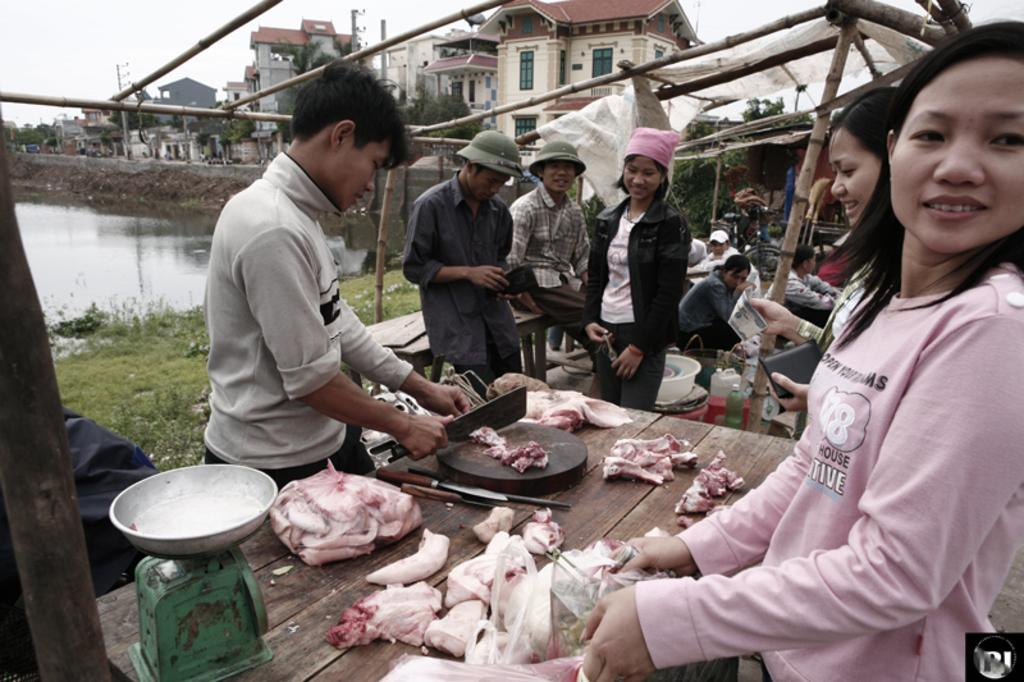What are the people in the image doing? There are people standing in the image, and one person is cutting meat. Can you describe the activities of the people in the background? In the background, there are people sitting. What can be seen in the distance behind the people? There are houses, a pond, and the sky visible in the background. What type of alarm can be heard going off in the image? There is no alarm present or audible in the image. What letters are being written by the person cutting meat in the image? The person cutting meat is not writing any letters in the image. 